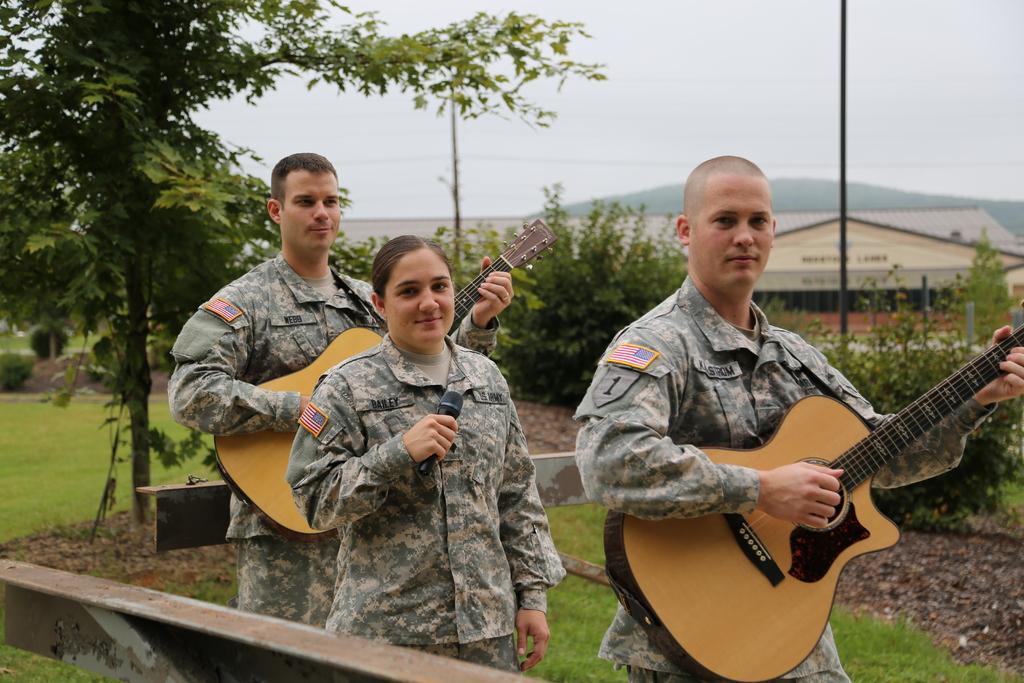Describe this image in one or two sentences. Here a woman holding mic in her hands and is in between two men,holding guitar in their hands. Behind her there is a tree,sky,pole and a building. 